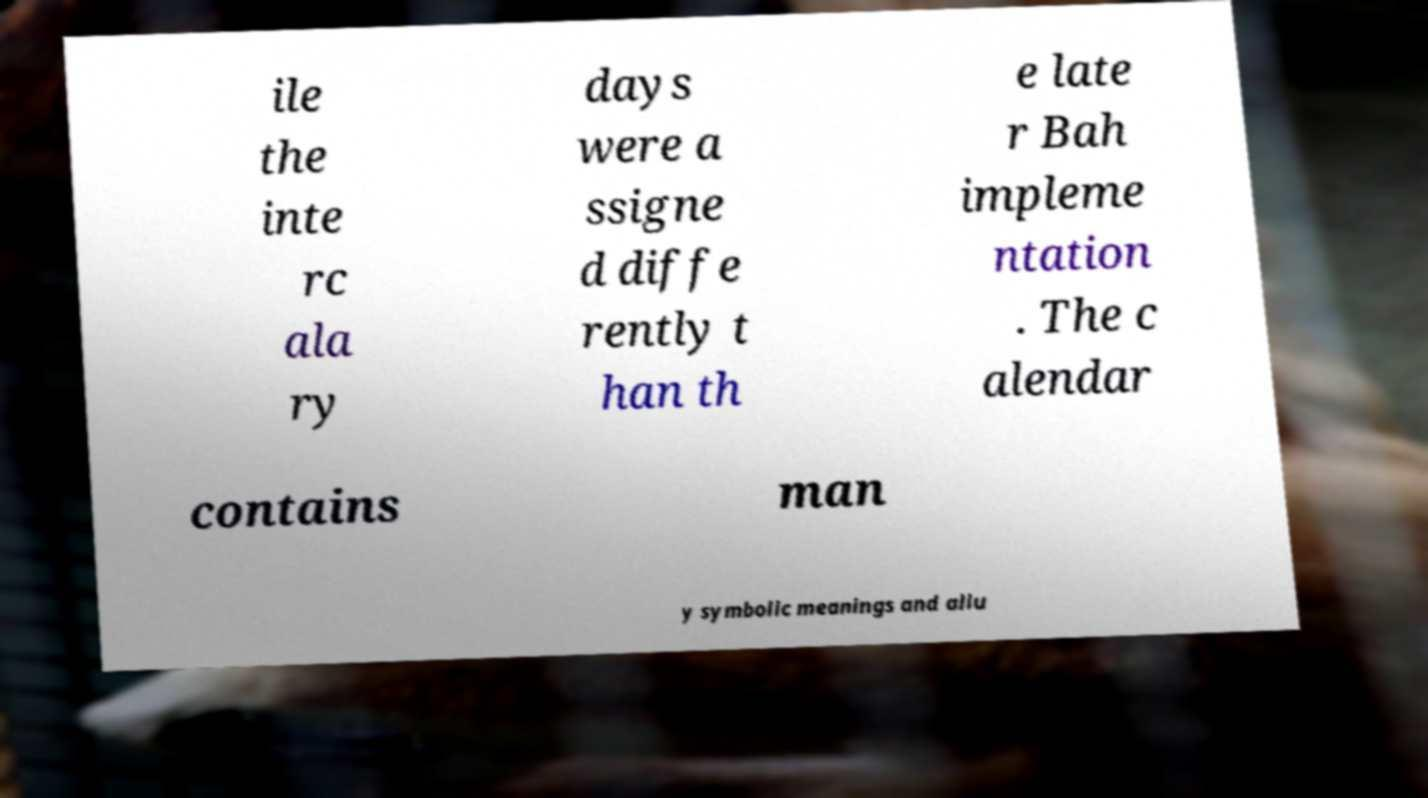Can you accurately transcribe the text from the provided image for me? ile the inte rc ala ry days were a ssigne d diffe rently t han th e late r Bah impleme ntation . The c alendar contains man y symbolic meanings and allu 